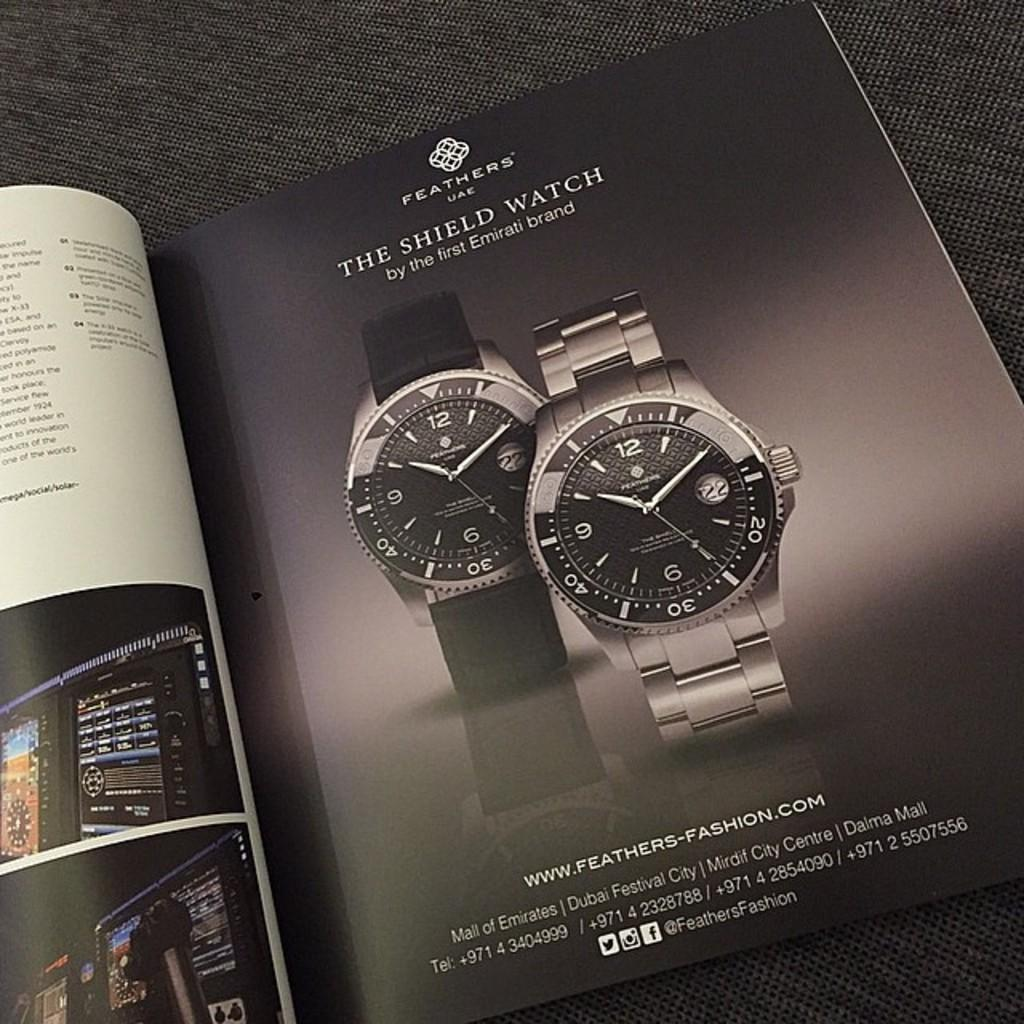<image>
Describe the image concisely. Magazine showing two watches and the word "The shield Watch" on the top. 